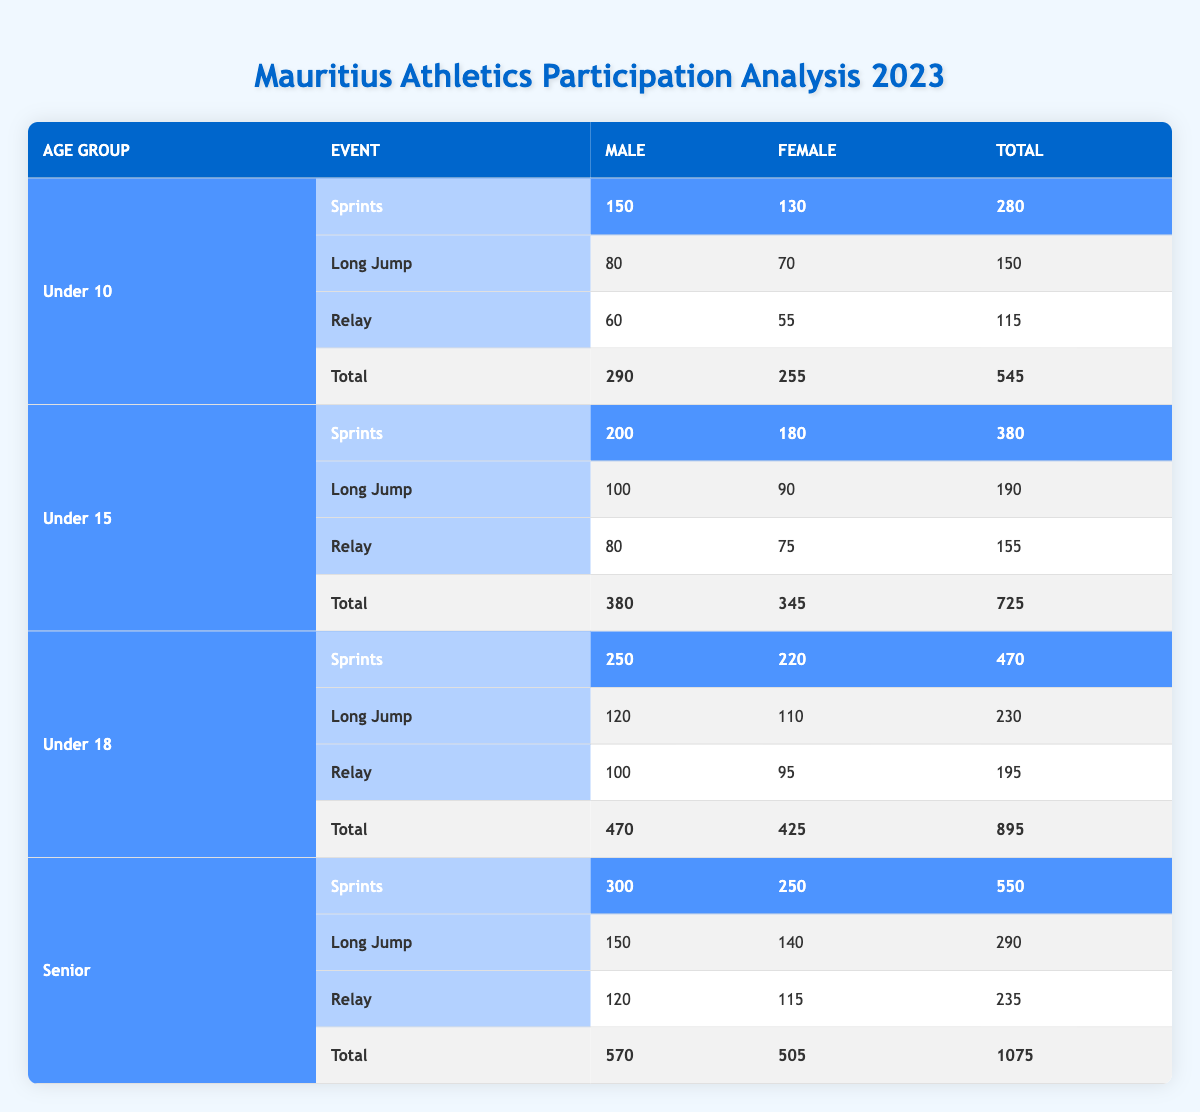What is the total number of participants in the Under 15 age group? The total participants for the Under 15 age group is listed in the last row of this section, which shows a total of 725 participants.
Answer: 725 How many more male participants are there in the Senior category than in the Under 10 category? The number of male participants in the Senior category is 570, and in the Under 10 category, it is 290. To find the difference, subtract: 570 - 290 = 280.
Answer: 280 What is the total number of female participants across all age groups? First, sum the total female participants in each age group: Under 10: 255, Under 15: 345, Under 18: 425, Senior: 505. Total: 255 + 345 + 425 + 505 = 1530.
Answer: 1530 Is it true that the total number of participants in the Under 18 category is greater than in the Senior category? The total participants in the Under 18 category is 895, while in the Senior category it is 1075. Since 895 is less than 1075, the statement is false.
Answer: No Which age group has the highest total number of participants, and what is that total? By comparing the total participants for each age group, we see Under 10 has 545, Under 15 has 725, Under 18 has 895, and Senior has 1075. The Senior age group has the highest total of 1075 participants.
Answer: Senior; 1075 Calculate the total number of participants in the Relay events for all age groups combined. To find this, add the total participants in the Relay events from each age group: Under 10: 115, Under 15: 155, Under 18: 195, Senior: 235. Total: 115 + 155 + 195 + 235 = 700.
Answer: 700 How many female participants competed in Sprints in the Under 15 category? The number of female participants in the Sprints for the Under 15 category is specified in the table as 180.
Answer: 180 What is the average total of participants in Long Jump events across all age groups? First, note the totals: Under 10: 150, Under 15: 190, Under 18: 230, and Senior: 290. The average can be calculated by summing these totals: 150 + 190 + 230 + 290 = 860, and then dividing by the number of age groups (4): 860/4 = 215.
Answer: 215 